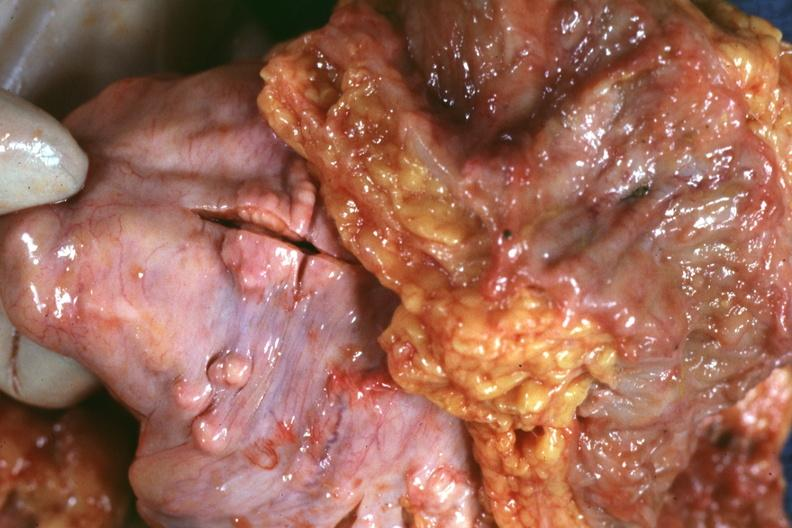s abdomen present?
Answer the question using a single word or phrase. No 